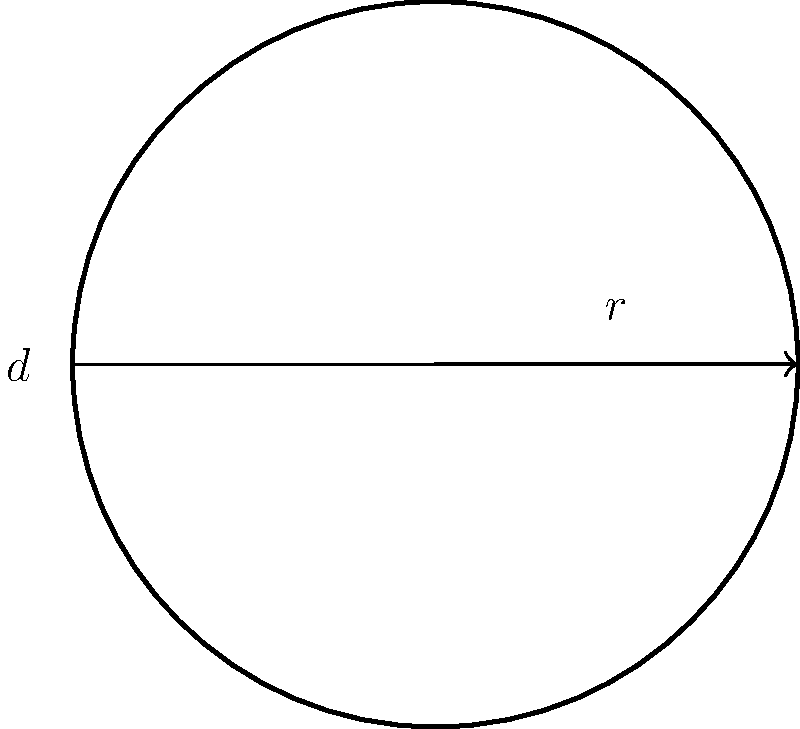As a football fan, you've been asked to help calculate the surface area of a new soccer ball design. The ball has a diameter of 22 cm. Assuming it's a perfect sphere, what is the total surface area of the ball? (Use $\pi \approx 3.14$ for your calculations) Let's approach this step-by-step:

1) First, recall the formula for the surface area of a sphere:
   $A = 4\pi r^2$, where $r$ is the radius of the sphere.

2) We're given the diameter $(d)$ of the ball, which is 22 cm. 
   The radius is half of the diameter: $r = \frac{d}{2}$

3) Calculate the radius:
   $r = \frac{22}{2} = 11$ cm

4) Now, let's substitute this into our formula:
   $A = 4\pi (11)^2$

5) Simplify:
   $A = 4\pi (121)$
   $A = 484\pi$

6) Using $\pi \approx 3.14$:
   $A \approx 484 * 3.14 = 1519.76$ cm²

7) Rounding to the nearest whole number:
   $A \approx 1520$ cm²
Answer: 1520 cm² 